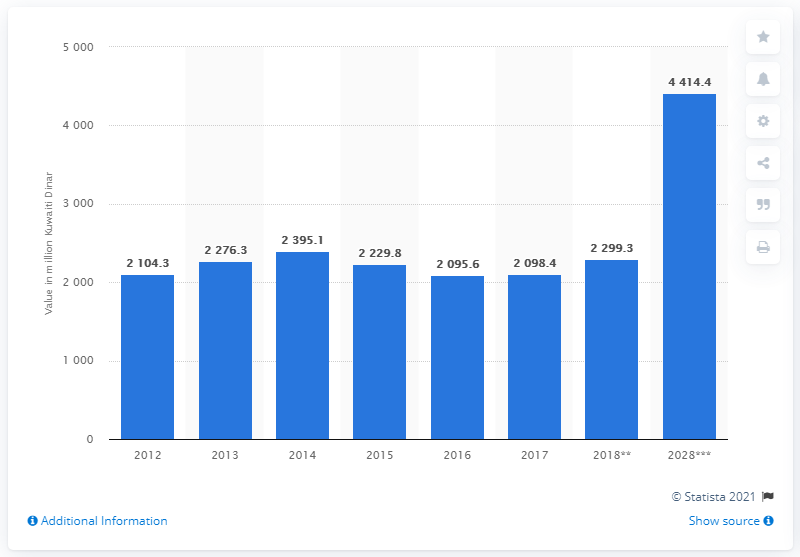Outline some significant characteristics in this image. The tourism and travel sector is projected to contribute 4414.4 Kuwaiti Dinar to the Gross Domestic Product (GDP) of Kuwait by the year 2028. 